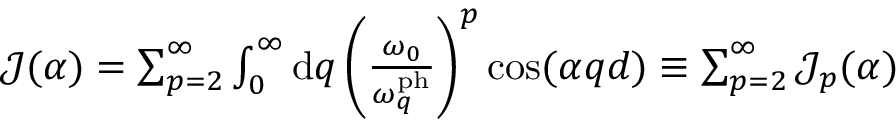<formula> <loc_0><loc_0><loc_500><loc_500>\begin{array} { r } { \mathcal { J } ( \alpha ) = \sum _ { p = 2 } ^ { \infty } \int _ { 0 } ^ { \infty } d q \left ( \frac { \omega _ { 0 } } { \omega _ { q } ^ { p h } } \right ) ^ { p } \cos ( \alpha q d ) \equiv \sum _ { p = 2 } ^ { \infty } \mathcal { J } _ { p } ( \alpha ) } \end{array}</formula> 